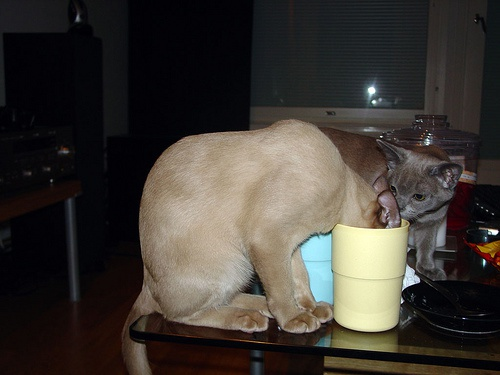Describe the objects in this image and their specific colors. I can see cat in black, darkgray, and gray tones, cat in black and gray tones, cup in black, beige, lightyellow, and tan tones, and cup in black, lightblue, teal, and darkgray tones in this image. 